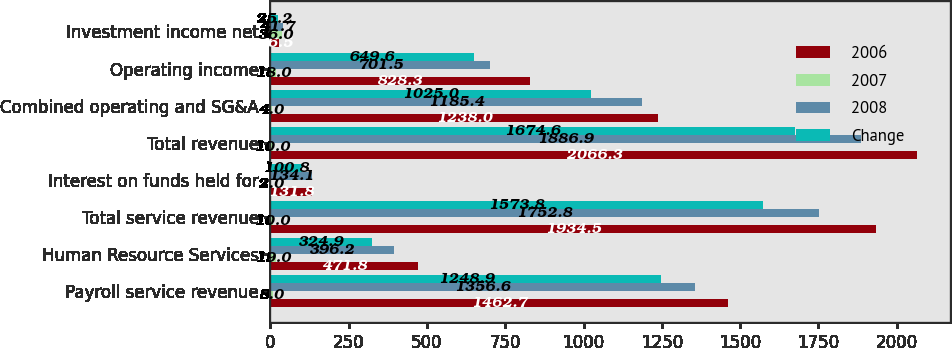<chart> <loc_0><loc_0><loc_500><loc_500><stacked_bar_chart><ecel><fcel>Payroll service revenue<fcel>Human Resource Services<fcel>Total service revenue<fcel>Interest on funds held for<fcel>Total revenue<fcel>Combined operating and SG&A<fcel>Operating income<fcel>Investment income net<nl><fcel>2006<fcel>1462.7<fcel>471.8<fcel>1934.5<fcel>131.8<fcel>2066.3<fcel>1238<fcel>828.3<fcel>26.5<nl><fcel>2007<fcel>8<fcel>19<fcel>10<fcel>2<fcel>10<fcel>4<fcel>18<fcel>36<nl><fcel>2008<fcel>1356.6<fcel>396.2<fcel>1752.8<fcel>134.1<fcel>1886.9<fcel>1185.4<fcel>701.5<fcel>41.7<nl><fcel>Change<fcel>1248.9<fcel>324.9<fcel>1573.8<fcel>100.8<fcel>1674.6<fcel>1025<fcel>649.6<fcel>25.2<nl></chart> 